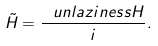<formula> <loc_0><loc_0><loc_500><loc_500>\tilde { H } = \frac { \ u n l a z i n e s s H } { \L i } .</formula> 